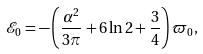Convert formula to latex. <formula><loc_0><loc_0><loc_500><loc_500>\mathcal { E } _ { 0 } = - \left ( \frac { \alpha ^ { 2 } } { 3 \pi } + 6 \ln 2 + \frac { 3 } { 4 } \right ) \varpi _ { 0 } ,</formula> 